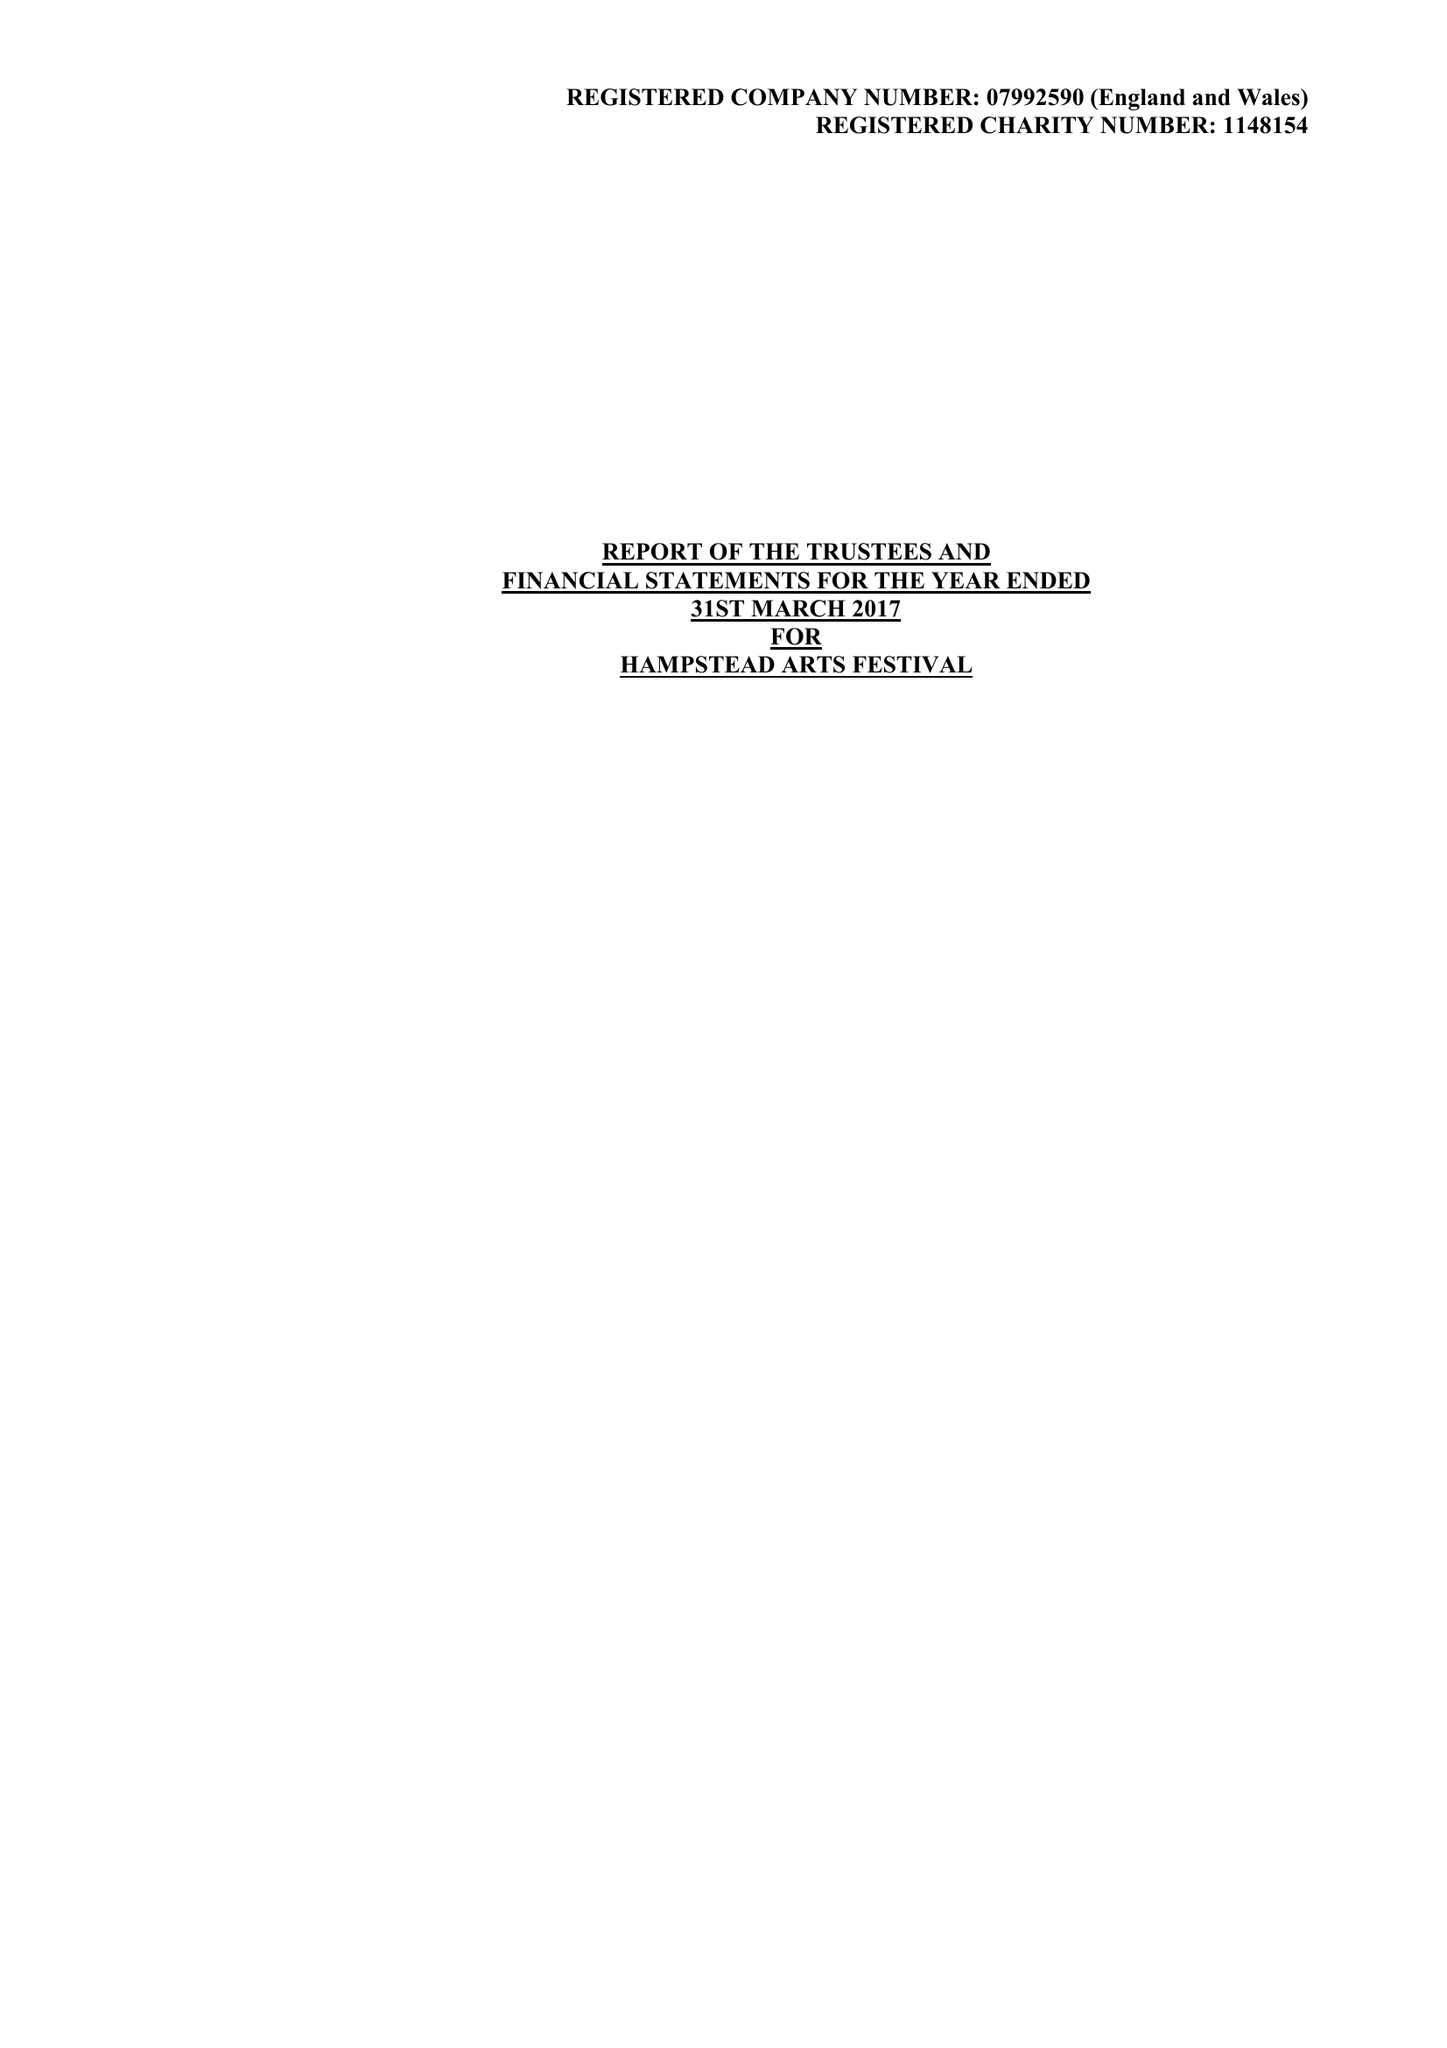What is the value for the charity_number?
Answer the question using a single word or phrase. 1148154 